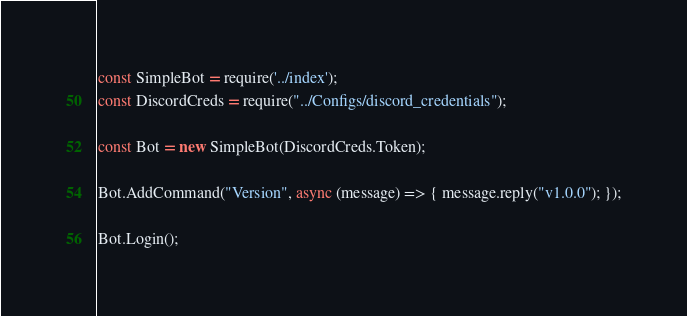<code> <loc_0><loc_0><loc_500><loc_500><_JavaScript_>const SimpleBot = require('../index');
const DiscordCreds = require("../Configs/discord_credentials");

const Bot = new SimpleBot(DiscordCreds.Token);

Bot.AddCommand("Version", async (message) => { message.reply("v1.0.0"); });

Bot.Login();</code> 